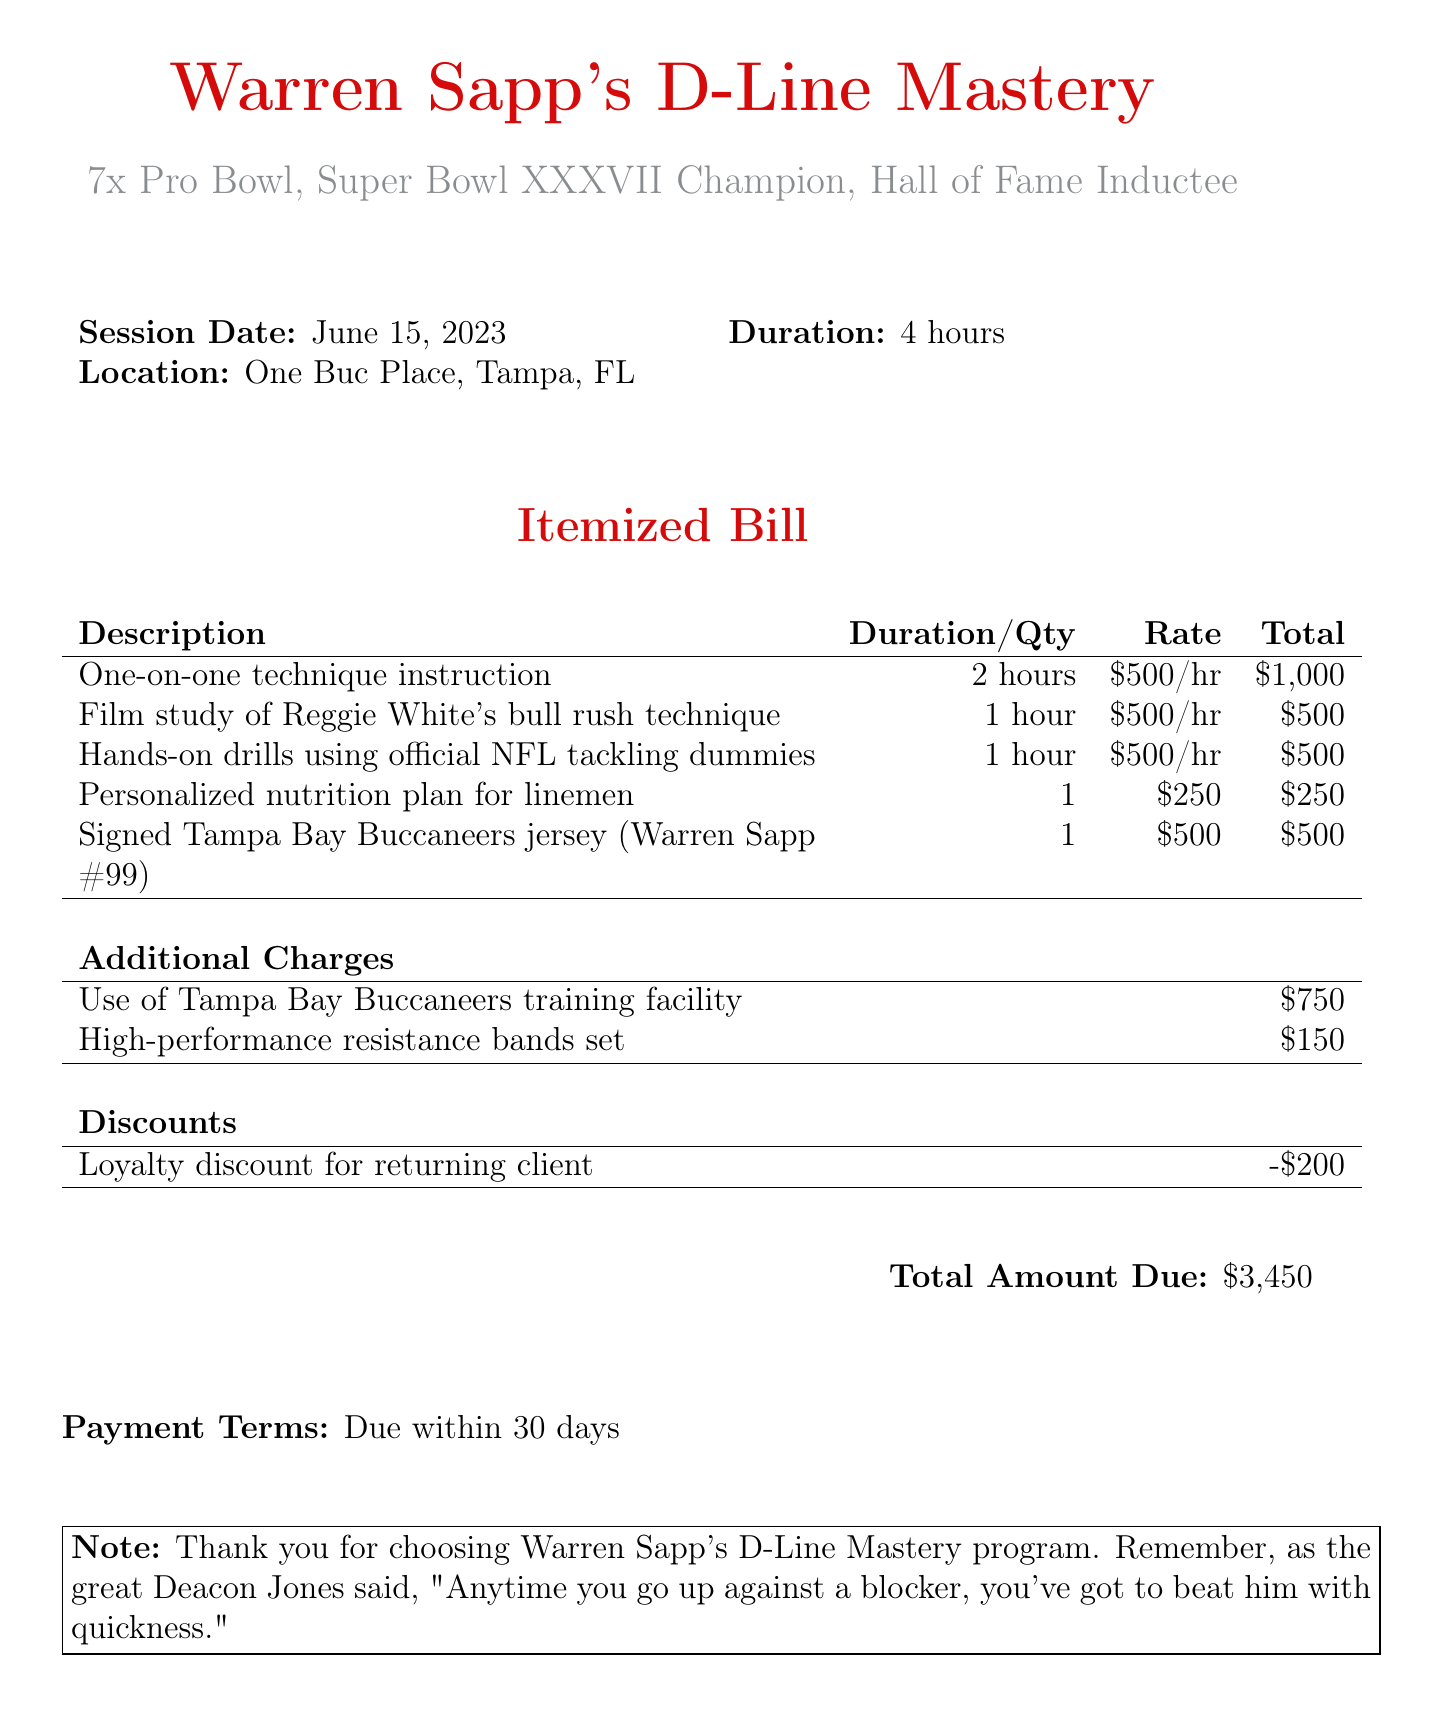What is the coach's name? The coach's name is listed at the top of the invoice as Warren Sapp.
Answer: Warren Sapp How many Pro Bowls has the coach been selected for? The invoice notes that the coach is a 7x Pro Bowl selection.
Answer: 7 What is the total amount due? The total amount due is specified at the bottom of the document.
Answer: $3,450 What is the date of the coaching session? The date of the session is prominently displayed in the invoice details.
Answer: June 15, 2023 How long was the session duration? The duration of the session is stated as 4 hours in the information table.
Answer: 4 hours What additional charge is listed for the use of the training facility? The document specifies an amount for the use of the training facility, which is an additional charge.
Answer: $750 What discount is provided on the invoice? The invoice states a loyalty discount for a returning client.
Answer: -$200 How much was charged for the signed jersey? The price for the signed jersey is indicated in the line items section of the invoice.
Answer: $500 What is the payment term listed? The payment terms detail the time frame in which payment is expected.
Answer: Due within 30 days 